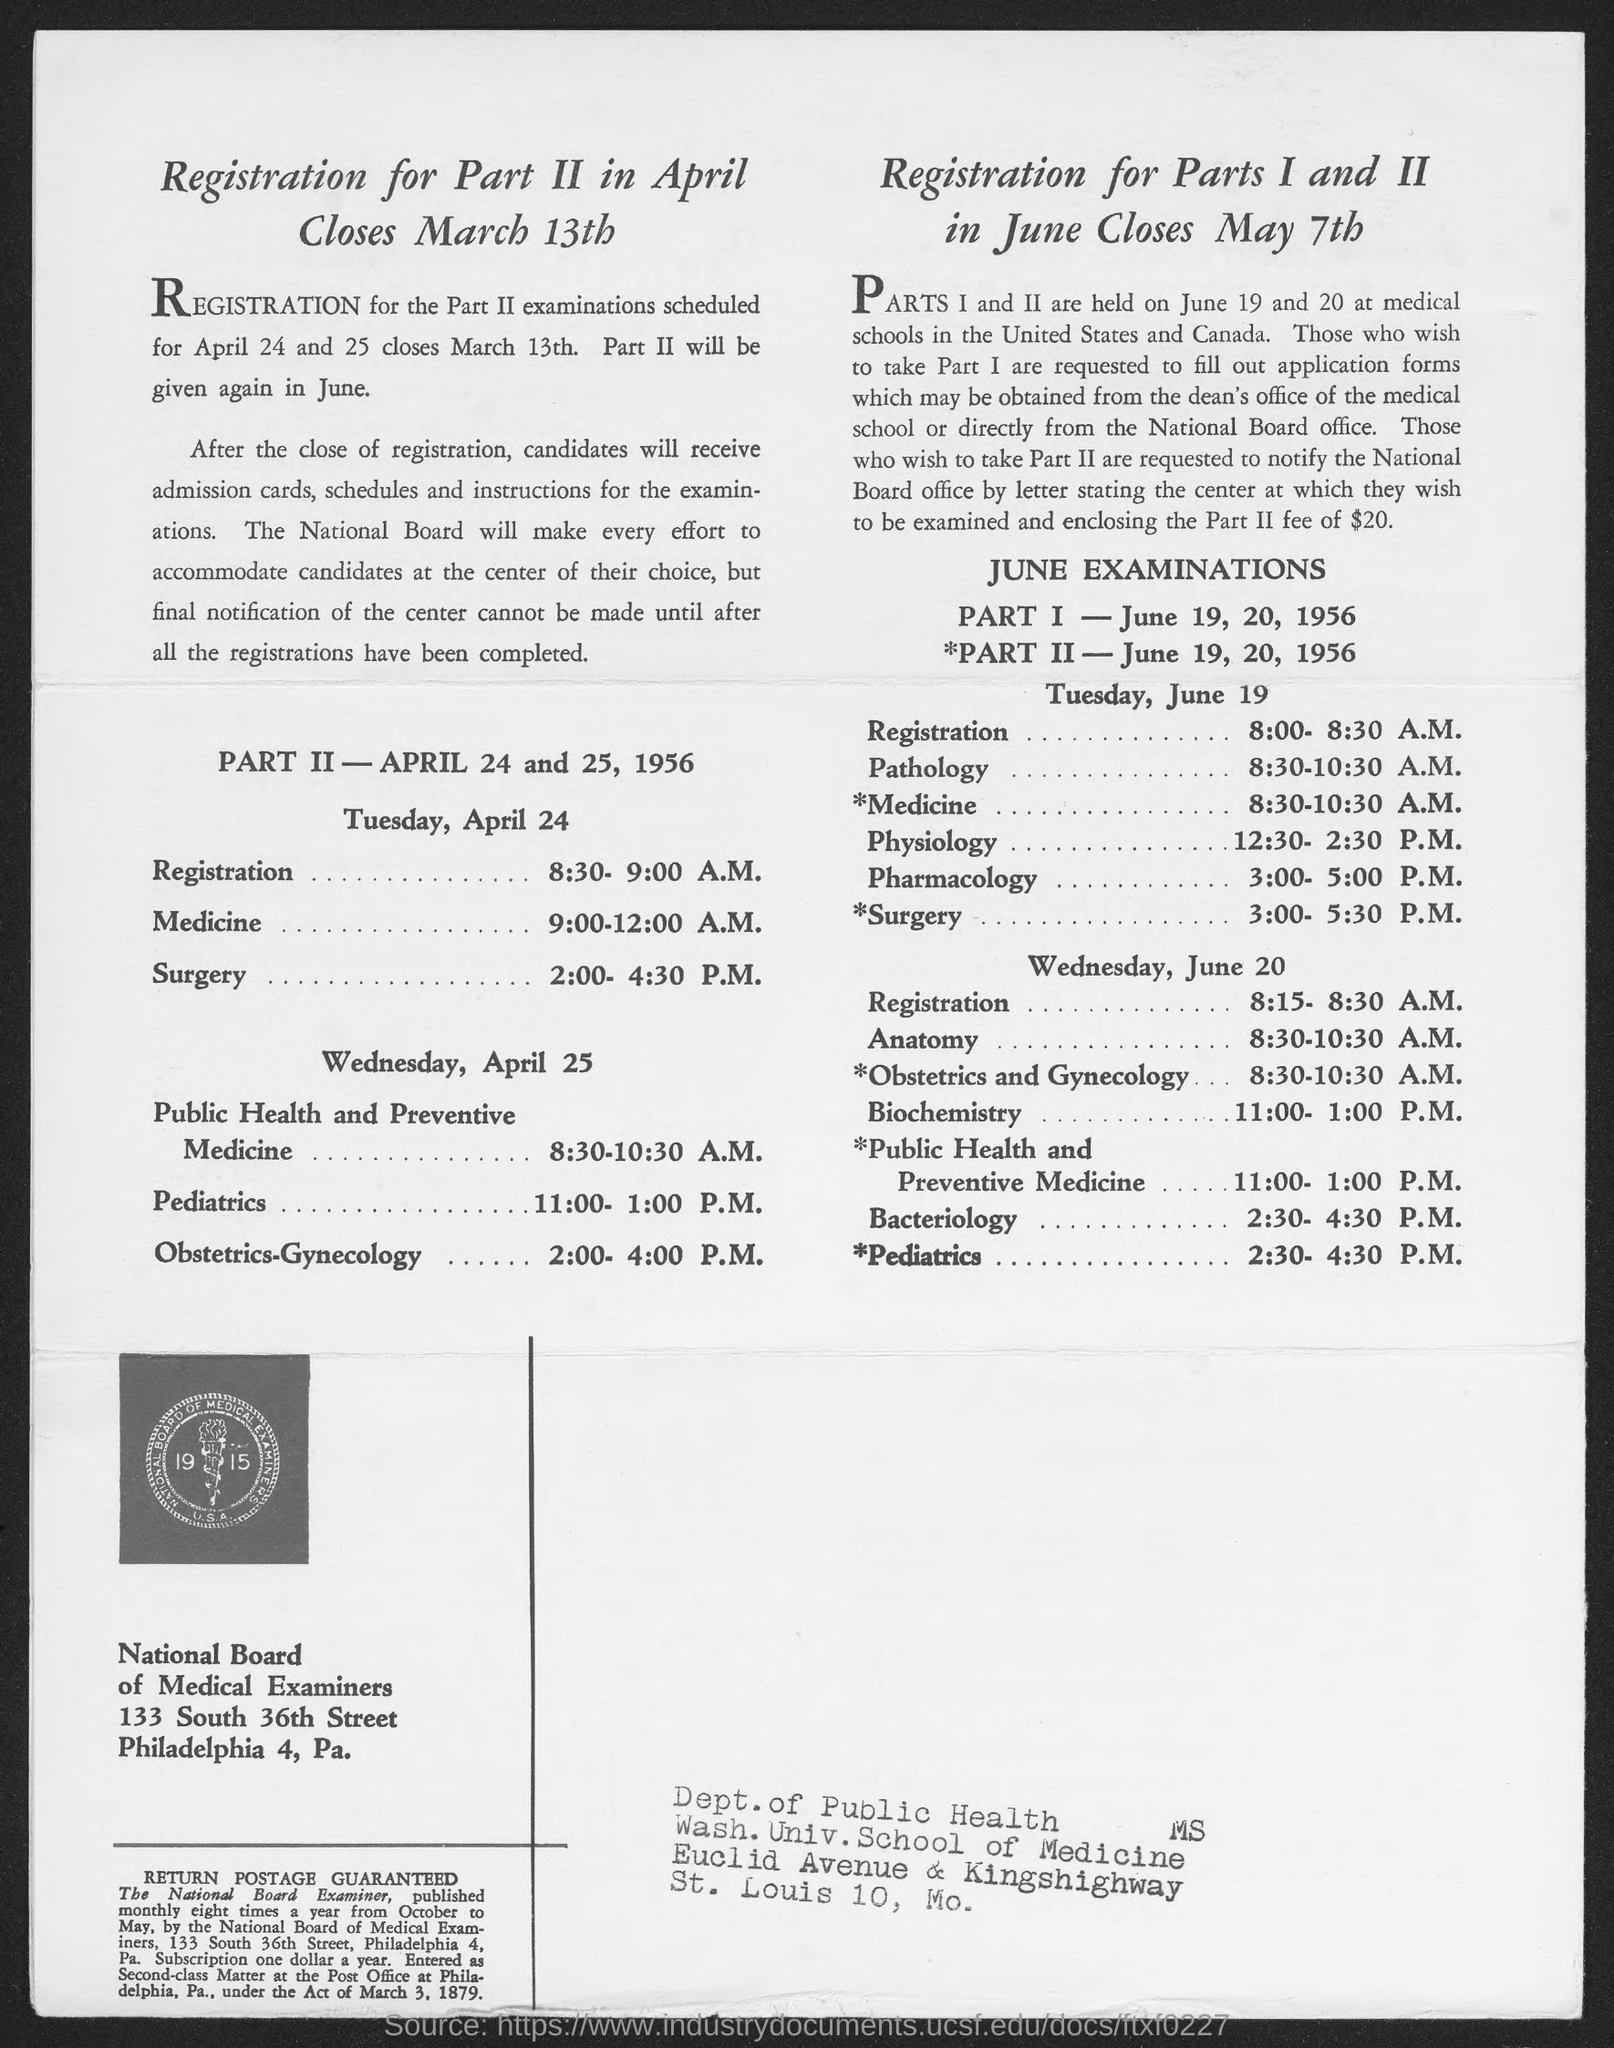Highlight a few significant elements in this photo. The National Board of Medical Examiners is mentioned in the text. The PART I JUNE EXAMINATIONS will be held on June 19, 20, and 1956. Registration for Part II in April will close on March 13th. The examination that will take place from 3:00-5:00 PM on Tuesday, June 19, is Pharmacology. The registration for Tuesday, April 24, will take place from 8:30-9:00 A.M. 